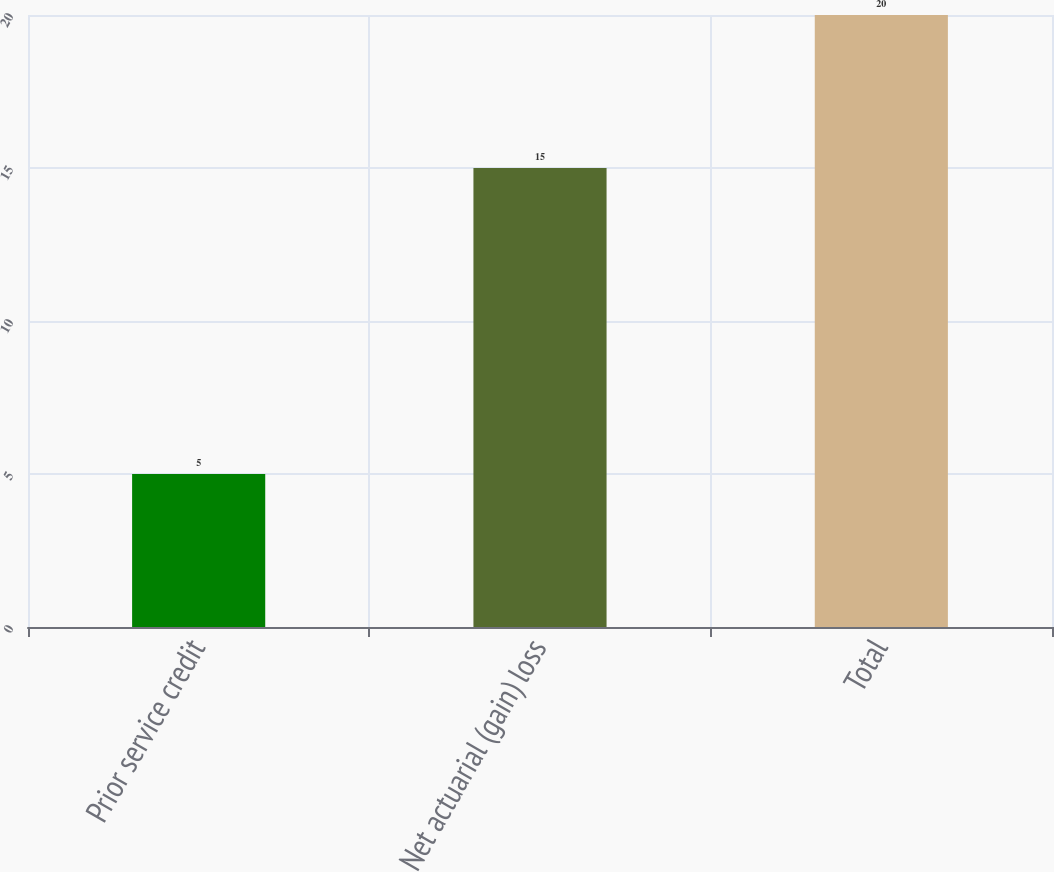<chart> <loc_0><loc_0><loc_500><loc_500><bar_chart><fcel>Prior service credit<fcel>Net actuarial (gain) loss<fcel>Total<nl><fcel>5<fcel>15<fcel>20<nl></chart> 